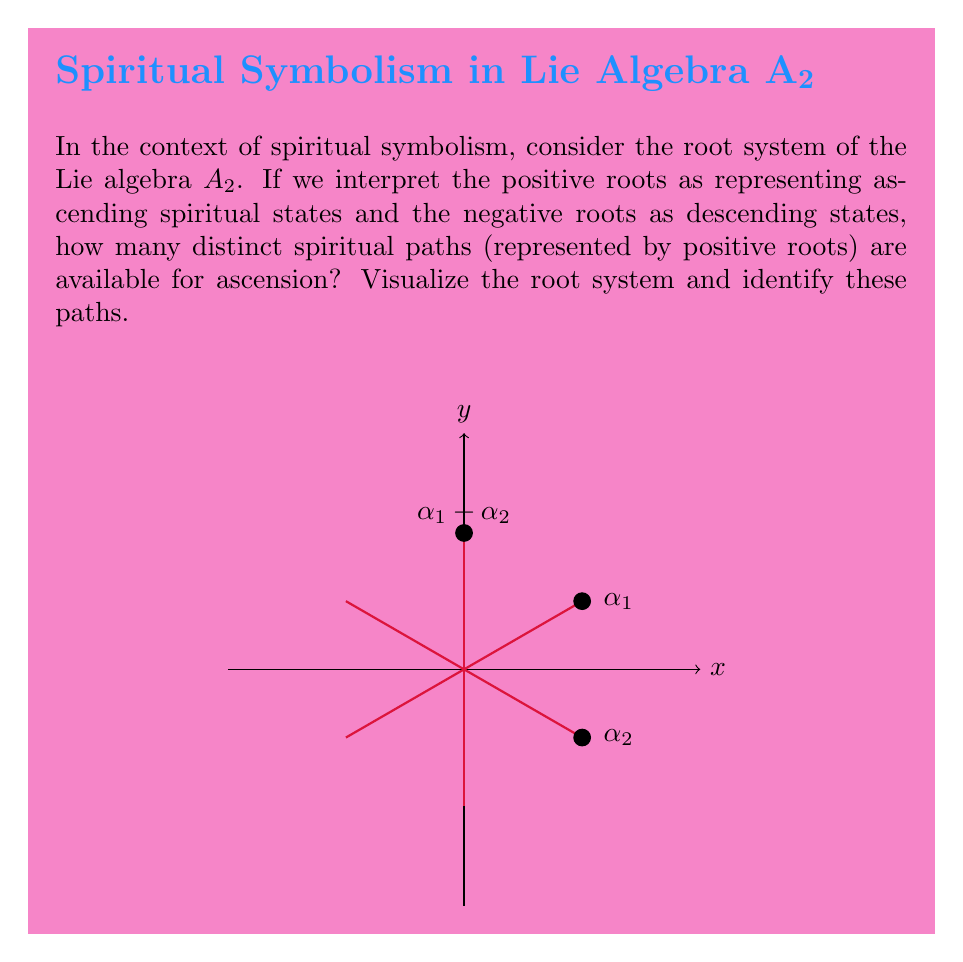Could you help me with this problem? To answer this question, let's examine the root system of the Lie algebra $A_2$ step by step:

1) The Lie algebra $A_2$ corresponds to $SU(3)$ or $SL(3,\mathbb{C})$. Its root system consists of six roots in a two-dimensional space.

2) In the diagram, we see three red lines passing through the origin. These represent the roots of $A_2$.

3) The positive roots are those pointing in the upper half-plane or to the right in the lower half-plane. From the diagram, we can identify three positive roots:

   a) $\alpha_1$: the root pointing up and to the right
   b) $\alpha_2$: the root pointing down and to the right
   c) $\alpha_1 + \alpha_2$: the root pointing straight up

4) In our spiritual interpretation:
   - $\alpha_1$ could represent a path of intellectual growth
   - $\alpha_2$ could represent a path of emotional development
   - $\alpha_1 + \alpha_2$ could represent a balanced path combining both intellectual and emotional growth

5) The negative roots (not labeled in the diagram) would represent the opposite or descending paths in each case.

6) Counting the positive roots, we find that there are 3 distinct "spiritual paths" for ascension in this symbolic representation.

This interpretation allows us to see the root system of $A_2$ as a metaphor for different approaches to spiritual growth, with the interaction and combination of different paths (roots) reflecting the complex nature of spiritual development.
Answer: 3 positive roots 